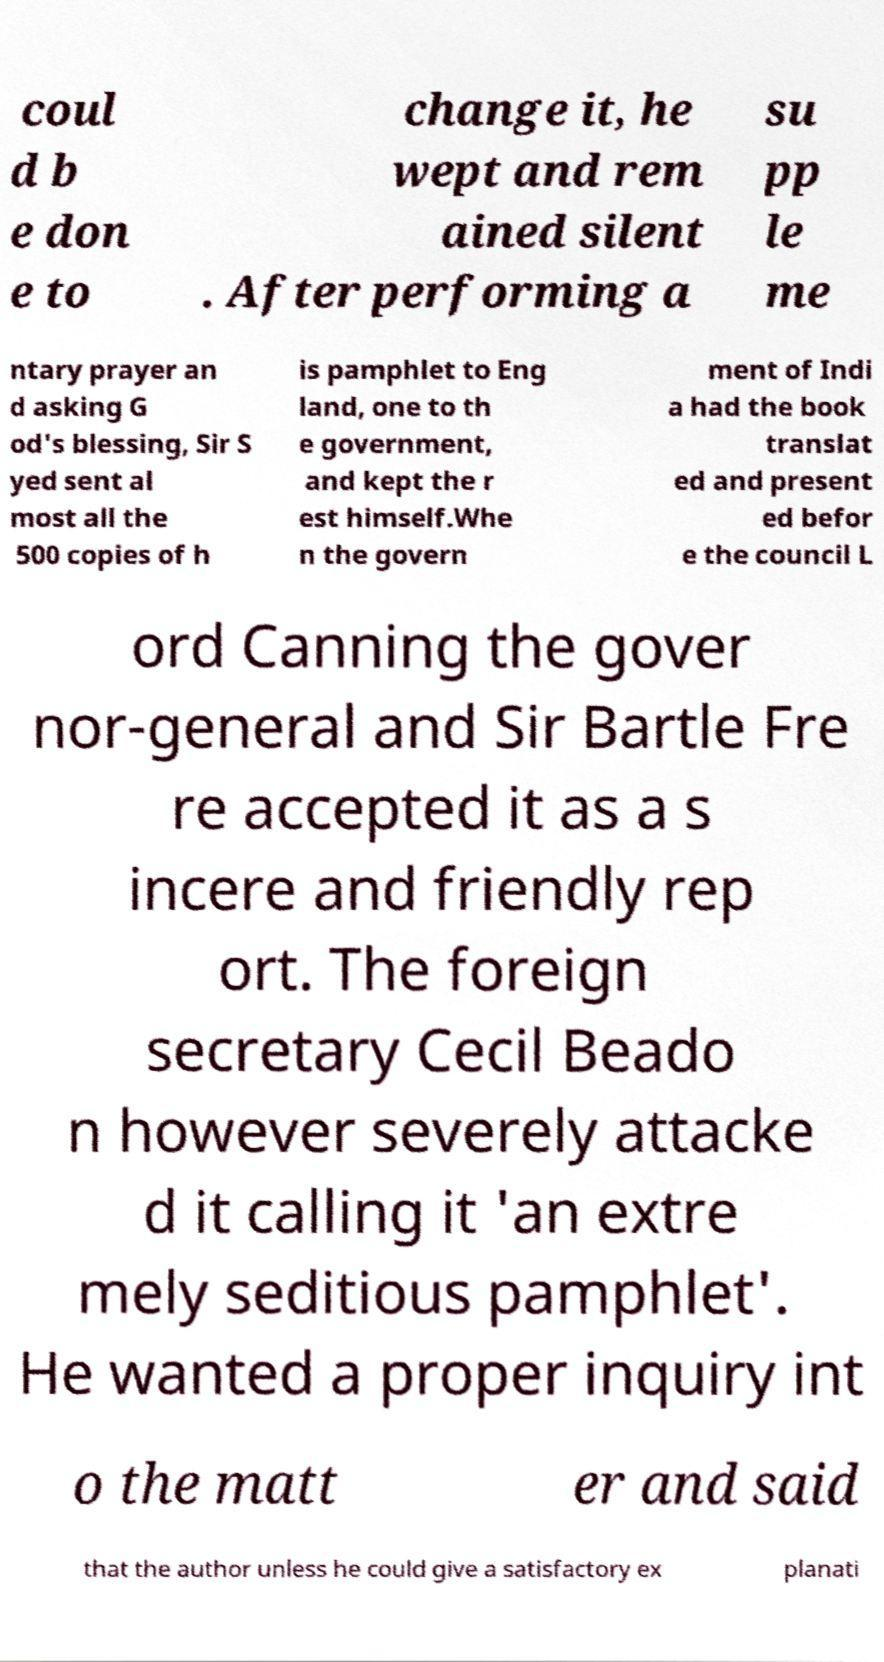Could you assist in decoding the text presented in this image and type it out clearly? coul d b e don e to change it, he wept and rem ained silent . After performing a su pp le me ntary prayer an d asking G od's blessing, Sir S yed sent al most all the 500 copies of h is pamphlet to Eng land, one to th e government, and kept the r est himself.Whe n the govern ment of Indi a had the book translat ed and present ed befor e the council L ord Canning the gover nor-general and Sir Bartle Fre re accepted it as a s incere and friendly rep ort. The foreign secretary Cecil Beado n however severely attacke d it calling it 'an extre mely seditious pamphlet'. He wanted a proper inquiry int o the matt er and said that the author unless he could give a satisfactory ex planati 